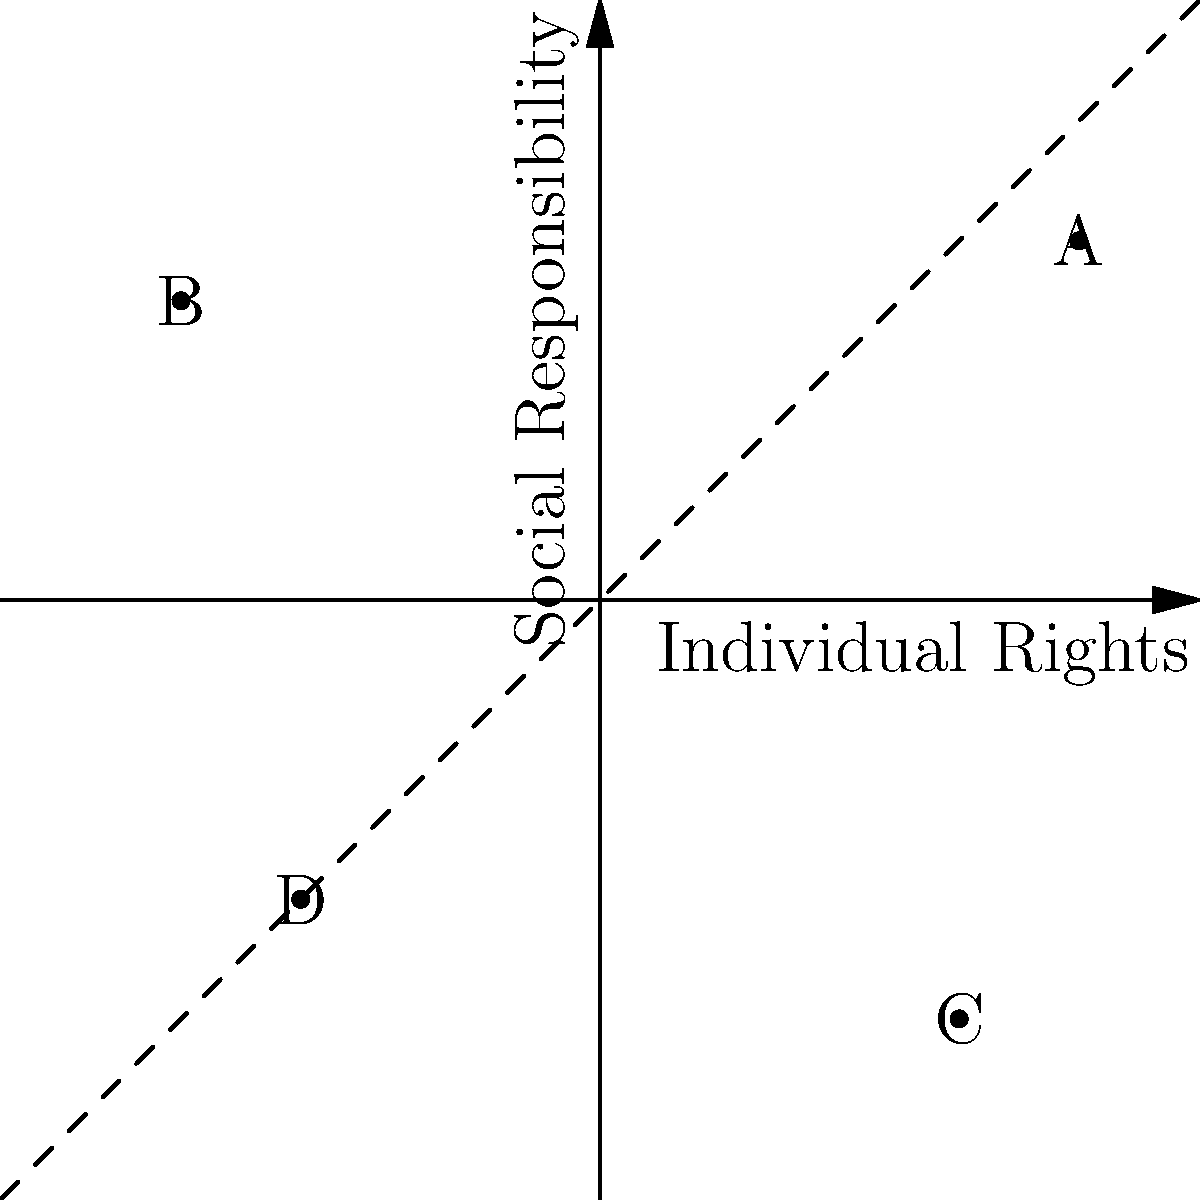In the moral compass coordinate system above, which quadrant represents ethical dilemmas where both individual rights and social responsibility are prioritized, and which point best represents a scenario where a news organization must decide whether to publish sensitive information that could benefit the public but potentially harm an individual's privacy? To answer this question, let's analyze the coordinate system and the ethical implications:

1. The x-axis represents Individual Rights, with positive values indicating higher priority.
2. The y-axis represents Social Responsibility, with positive values indicating higher priority.
3. The four quadrants represent different ethical stances:
   - Quadrant I (top-right): High Individual Rights, High Social Responsibility
   - Quadrant II (top-left): Low Individual Rights, High Social Responsibility
   - Quadrant III (bottom-left): Low Individual Rights, Low Social Responsibility
   - Quadrant IV (bottom-right): High Individual Rights, Low Social Responsibility

4. Quadrant I (top-right) represents scenarios where both individual rights and social responsibility are prioritized.

5. The scenario of publishing sensitive information that could benefit the public but potentially harm an individual's privacy presents a dilemma between social responsibility (informing the public) and individual rights (privacy).

6. Point A (0.8, 0.6) is in Quadrant I and represents a balance between high individual rights and high social responsibility, which best fits the described scenario.
Answer: Quadrant I; Point A 